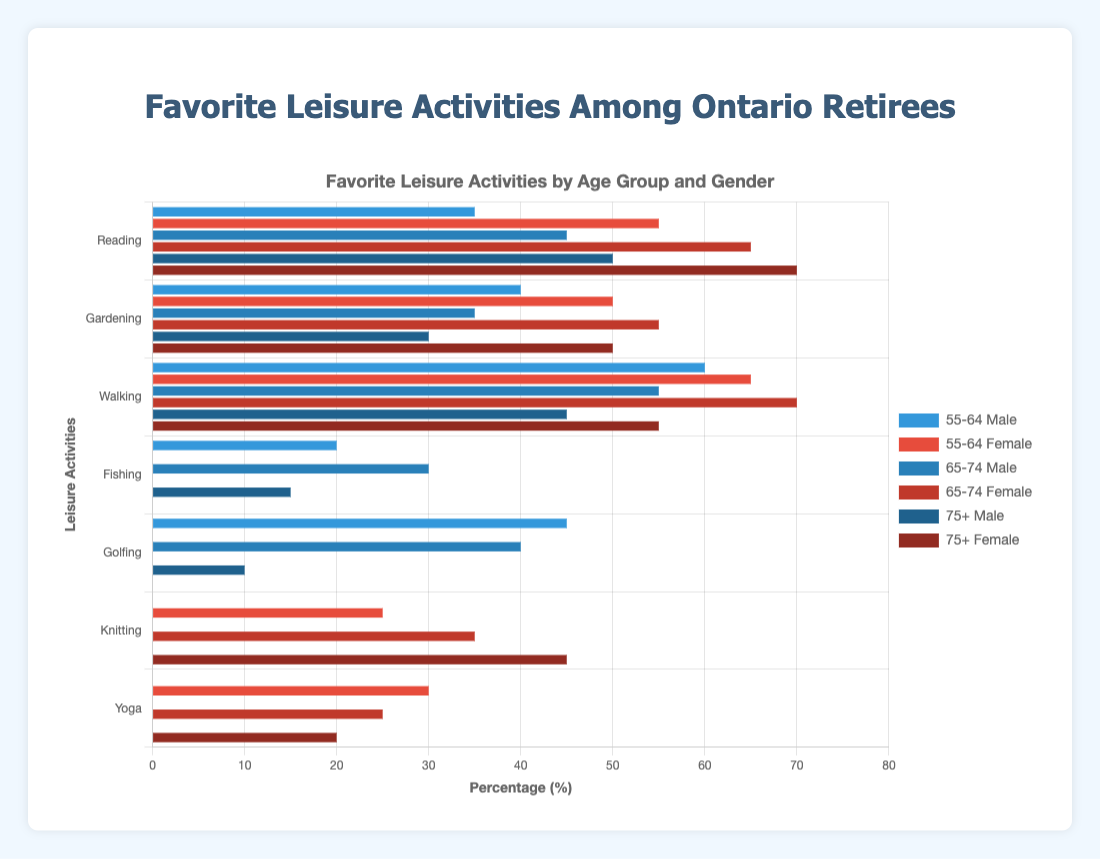What is the most popular leisure activity for males in the 55-64 age group? To find the most popular leisure activity for males aged 55-64, look at the bars representing that demographic group and identify the tallest bar. The tallest bar corresponds to Walking, with 60%.
Answer: Walking Which age group and gender combination has the highest percentage for reading? Compare the heights of the bars for Reading across all age and gender groups. The bar for Reading in the 75+ female group is the highest, indicating this combination has the highest percentage for Reading.
Answer: 75+ Female What is the difference in the percentage of Gardening between males aged 55-64 and 65-74? Examine the bars for Gardening in the males 55-64 and 65-74 groups. The percentage for males aged 55-64 is 40%, and for males aged 65-74 is 35%. Calculate the difference: 40 - 35 = 5%.
Answer: 5% Which activity shows a higher percentage among females aged 75+: Knitting or Yoga? Look at the bars for Knitting and Yoga in the females aged 75+ group. Knitting has a height of 45%, and Yoga has a height of 20%. Therefore, Knitting shows a higher percentage.
Answer: Knitting What are the combined percentages for Reading among all male age groups? Identify the heights of Reading bars for all male age groups: 55-64 (35%), 65-74 (45%), and 75+ (50%). Add these values: 35 + 45 + 50 = 130%.
Answer: 130% How many percentage points higher is female Gardening in the 65-74 age group compared to the 55-64 age group? Compare the bars for Gardening in the females 65-74 (55%) and 55-64 (50%). Calculate the difference: 55 - 50 = 5 percentage points.
Answer: 5 Which gender engages more in Yoga in the 55-64 age group? Compare the heights of the Yoga bars for males and females in the 55-64 age group. Males do not have a bar for Yoga, while females have 30%. So, females engage more in Yoga.
Answer: Female What is the least popular activity among males in the 75+ age group? Identify the shortest bar for males aged 75+. The shortest bar corresponds to Golfing, with 10%.
Answer: Golfing What is the average percentage of Walking for males across all age groups? Identify the percentages for Walking in all male age groups: 55-64 (60%), 65-74 (55%), 75+ (45%). Calculate the average: (60 + 55 + 45) / 3 = 160 / 3 ≈ 53.3%.
Answer: 53.3% Which leisure activity shows the smallest range of participation percentages across all demographic groups? Examine the range (difference between the highest and lowest values) for each activity. Knitting is only relevant for females, with the smallest range between 45% and 25%, a range of 20%.
Answer: Knitting 